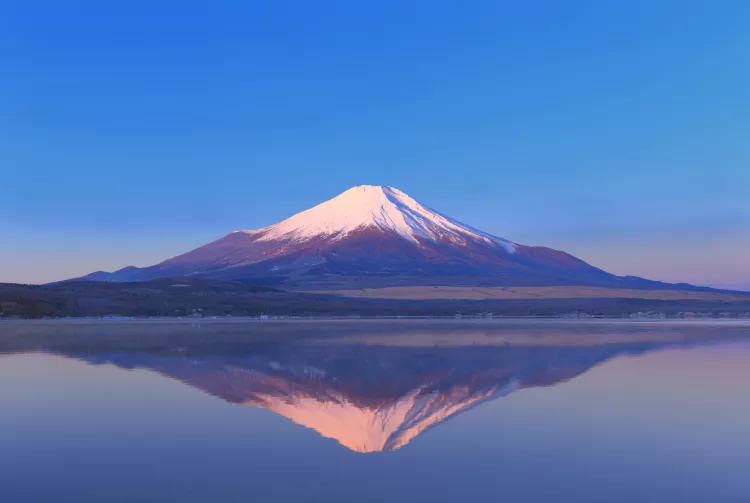What are the key elements in this picture? The image presents a breathtaking view of Mount Fuji in Japan, prominently covered in snow, reflecting the early morning light that casts a soft pink hue at its peak. The tranquil light blue sky forms a serene backdrop, enhancing the mountain's majestic presence. Below, the mirror-like waters create a stunning reflection of Mount Fuji, doubling its visual impact. Shot from a low angle, the photograph emphasizes the grand scale and revered beauty of this iconic mountain, inviting the viewer to appreciate its serene yet imposing stature. 